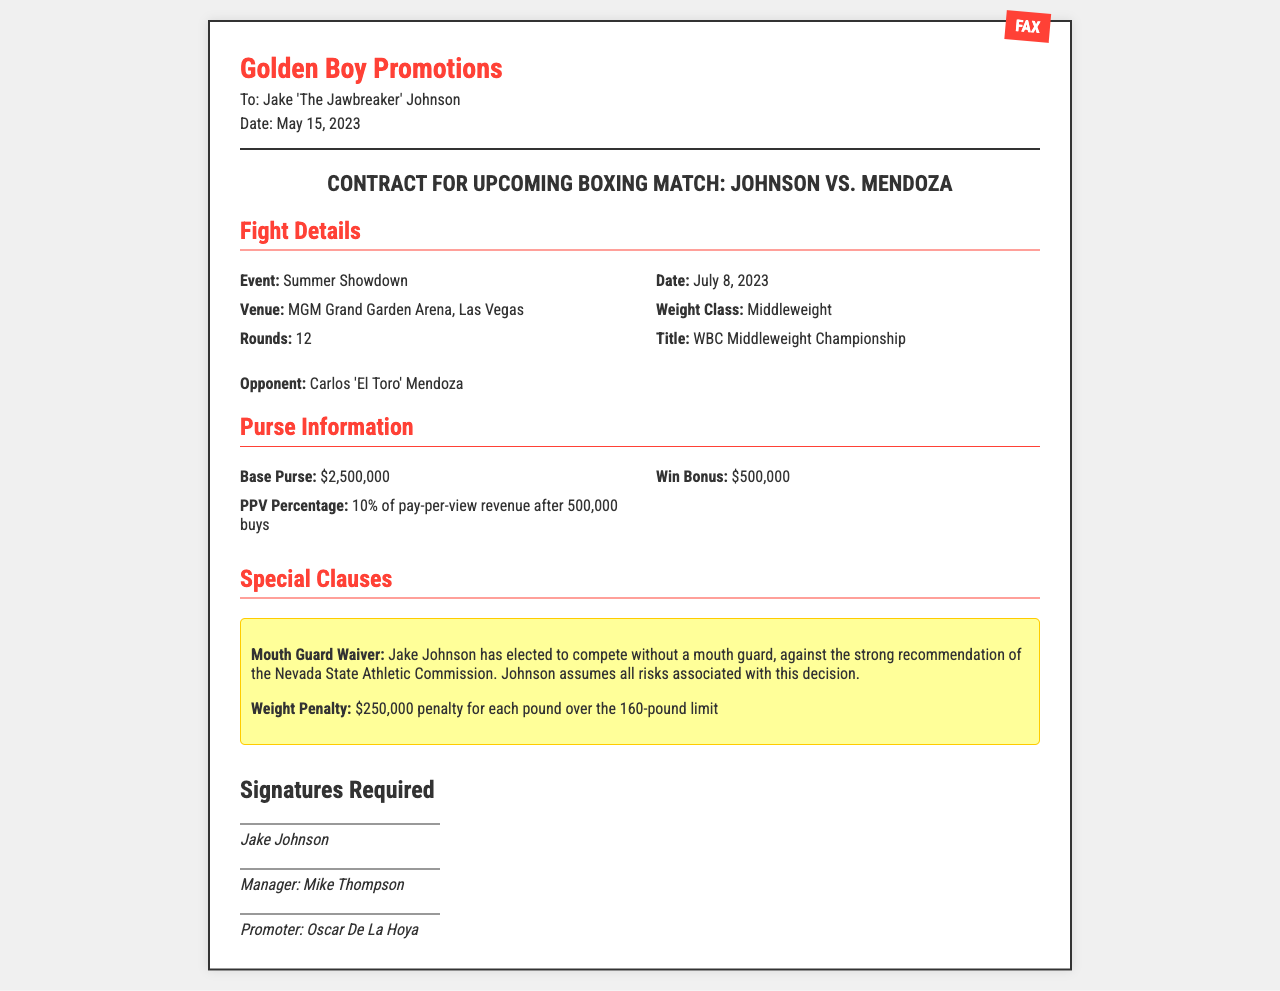What is the event name? The event name is explicitly stated in the document under fight details.
Answer: Summer Showdown What is the date of the match? The date of the match can be found under fight details.
Answer: July 8, 2023 What is the venue for the fight? The venue is listed in the fight details section.
Answer: MGM Grand Garden Arena, Las Vegas Who is the opponent? The opponent is mentioned directly in the fight details section.
Answer: Carlos 'El Toro' Mendoza What is the base purse amount? The base purse is specified in the purse information section.
Answer: $2,500,000 What is the win bonus? The win bonus is noted in the purse information details.
Answer: $500,000 What is the penalty for exceeding the weight limit? The penalty for weight excess is outlined under special clauses.
Answer: $250,000 per pound What option has Jake Johnson chosen regarding the mouth guard? The specific decision made by Jake Johnson related to the mouth guard is stated in the special clauses section.
Answer: Compete without a mouth guard Who is the promoter? The promoter's name is required in the signatures section of the document.
Answer: Oscar De La Hoya 